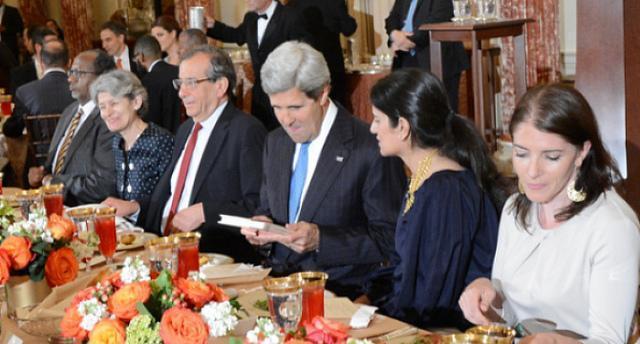How many people are there?
Give a very brief answer. 10. 